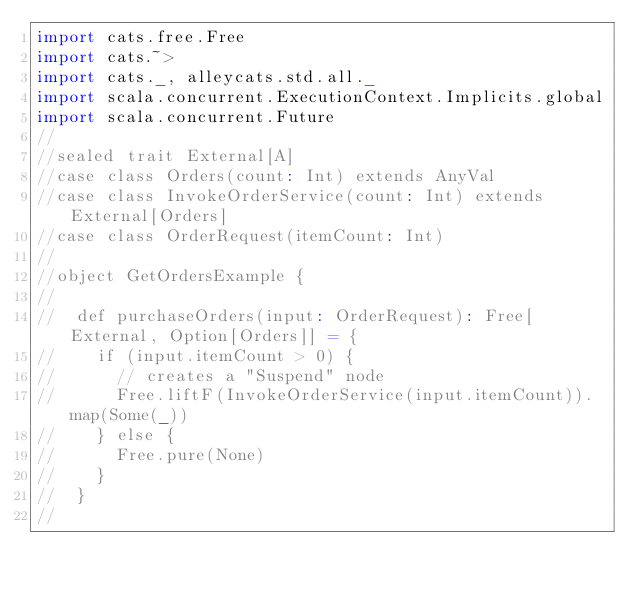Convert code to text. <code><loc_0><loc_0><loc_500><loc_500><_Scala_>import cats.free.Free
import cats.~>
import cats._, alleycats.std.all._
import scala.concurrent.ExecutionContext.Implicits.global
import scala.concurrent.Future
//
//sealed trait External[A]
//case class Orders(count: Int) extends AnyVal
//case class InvokeOrderService(count: Int) extends External[Orders]
//case class OrderRequest(itemCount: Int)
//
//object GetOrdersExample {
//
//  def purchaseOrders(input: OrderRequest): Free[External, Option[Orders]] = {
//    if (input.itemCount > 0) {
//      // creates a "Suspend" node
//      Free.liftF(InvokeOrderService(input.itemCount)).map(Some(_))
//    } else {
//      Free.pure(None)
//    }
//  }
//</code> 